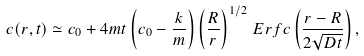Convert formula to latex. <formula><loc_0><loc_0><loc_500><loc_500>c ( r , t ) \simeq c _ { 0 } + 4 m t \left ( c _ { 0 } - \frac { k } { m } \right ) \left ( \frac { R } { r } \right ) ^ { 1 / 2 } \, E r f c \left ( \frac { r - R } { 2 \sqrt { D t } } \right ) ,</formula> 